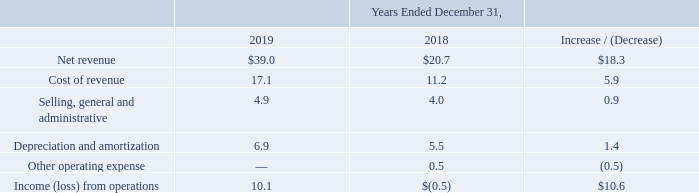Net revenue: Net revenue from our Energy segment for the year ended December 31, 2019 increased $18.3 million to $39.0 million from $20.7 million for the year ended December 31, 2018. The increase was primarily driven by the AFTC related to the 2018 and 2019 CNG sales that was recognized in the fourth quarter of 2019, inclusive of prior period AFTC at the acquired ampCNG stations which was also recognized in 2019. The increase was also driven by higher volume-related revenues from the recent acquisition of the ampCNG stations and growth in CNG sales volumes.
Cost of revenue: Cost of revenue from our Energy segment for the year ended December 31, 2019 increased $5.9 million to $17.1 million from $11.2 million for the year ended December 31, 2018. The increase was due to overall growth in volumes of gasoline gallons delivered and higher commodity and utility costs driven by the acquisition of ampCNG stations.
Selling, general and administrative: Selling, general and administrative expenses from our Energy segment for the year ended December 31, 2019 increased $0.9 million to $4.9 million from $4.0 million for the year ended December 31, 2018. The increase was driven by an increase in salaries and benefits largely due to the of the acquisition of ampCNG stations, which were acquired late in the second quarter of 2019, partially offset by a one-time expense in the prior year related to the abandonment of a station development project.
Depreciation and amortization from our Energy segment for the year ended December 31, 2019 increased $1.4 million to $6.9 million from $5.5 million for the year ended December 31, 2018. The increase was due to additional depreciation and amortization from the recent acquisition of ampCNG stations.
Other operating expense from our Energy segment was a loss of $0.5 million for the year ended December 31, 2018, driven by impairment of certain stations during the fourth quarter of 2018.
What was the net revenue for the year ended December 31, 2019? $39.0 million. What was the net revenue for the year ended December 31, 2018? $20.7 million. What was the cost of revenue for the year ended December 31, 2019? $17.1 million. What was the percentage increase / (decrease) in the net revenue from 2018 to 2019?
Answer scale should be: percent. 39.0 / 20.7 - 1
Answer: 88.41. What was the average cost of revenue?
Answer scale should be: million. (17.1 + 11.2) / 2
Answer: 14.15. What is the percentage increase / (decrease) in the Depreciation and amortization from 2018 to 2019?
Answer scale should be: percent. 6.9 / 5.5 - 1
Answer: 25.45. 